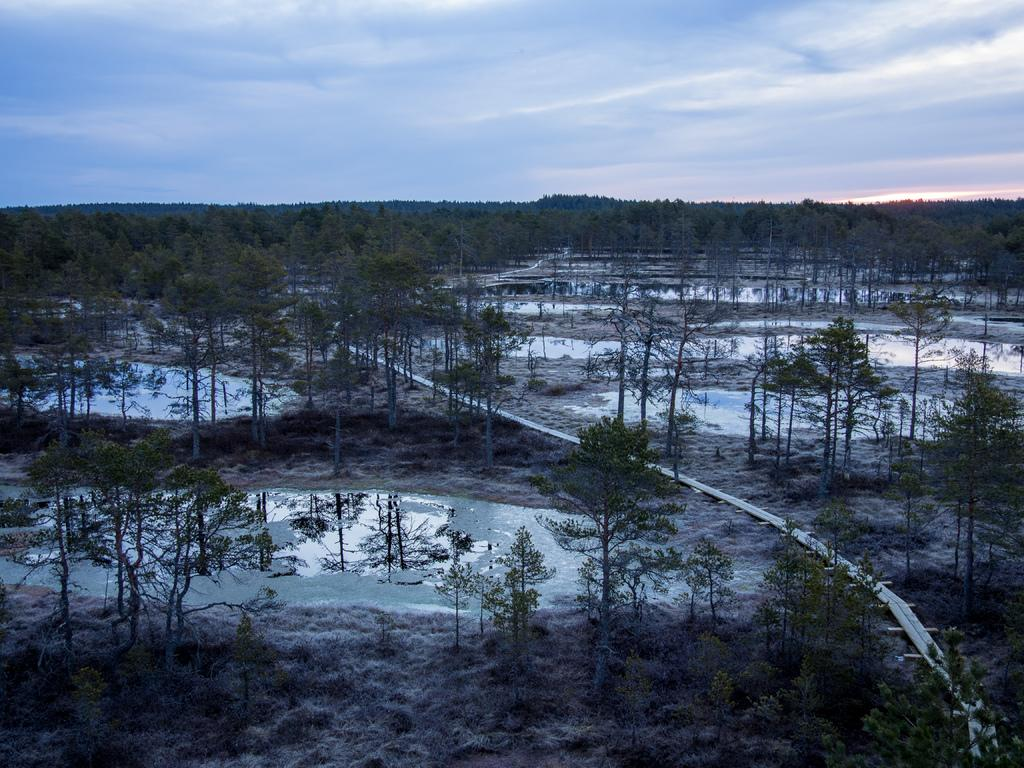What type of vegetation can be seen in the image? There are trees in the image. What natural element is visible in the image besides the trees? There is water visible in the image. Can you describe the object in the image? Unfortunately, the facts provided do not give enough information to describe the object in the image. What is the condition of the sky in the image? The sky is cloudy and visible at the top of the image. What type of bread is being served to the family in the image? There is no family or bread present in the image. 